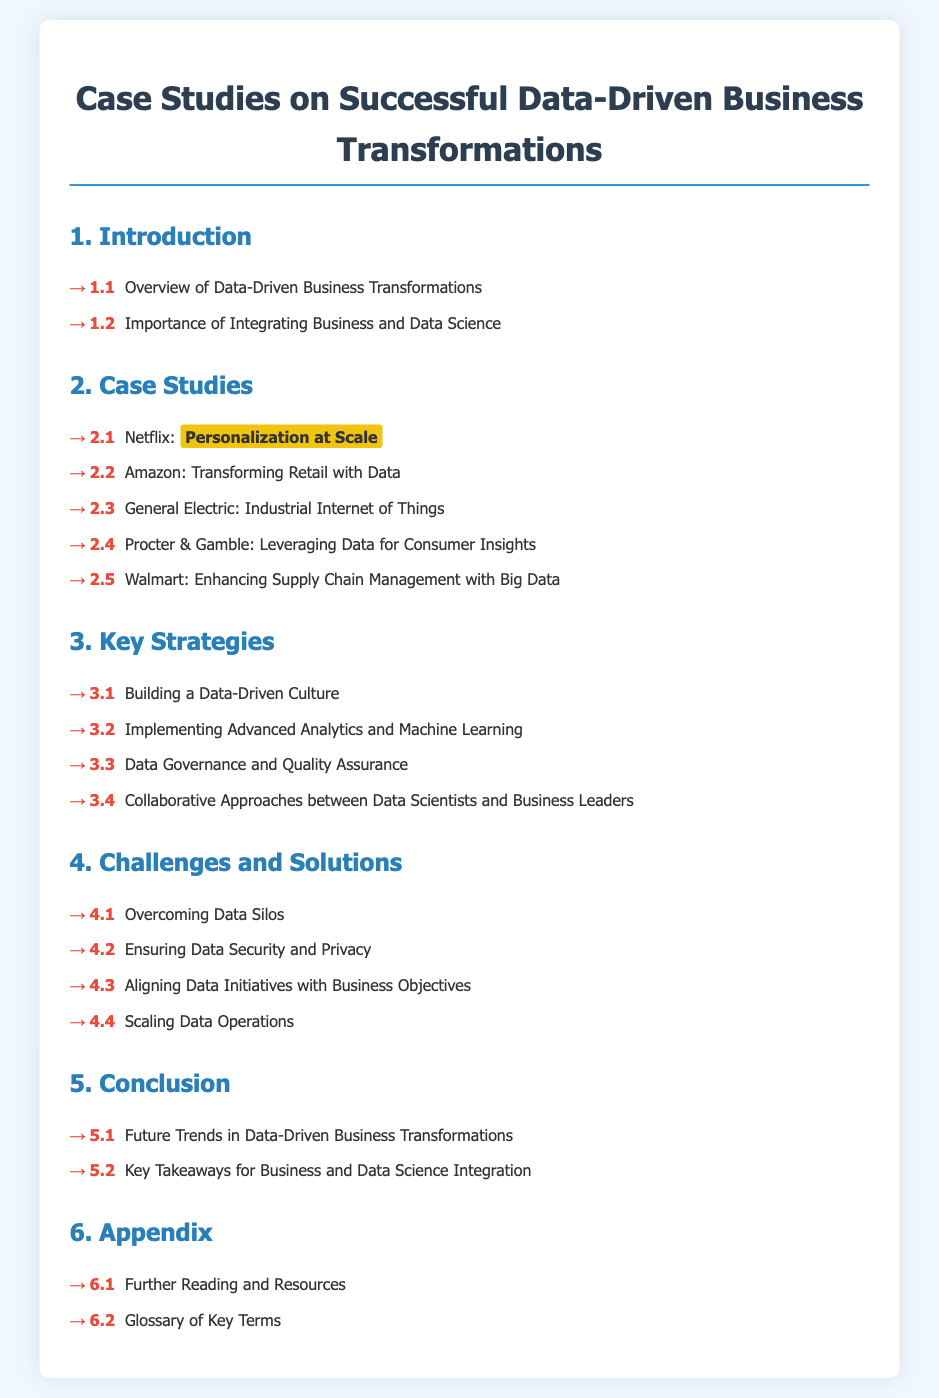what is the title of the document? The title is displayed prominently at the top of the document.
Answer: Case Studies on Successful Data-Driven Business Transformations how many case studies are listed in section 2? Each case study is listed under section 2 with specific numbering.
Answer: 5 which company is associated with 'Personalization at Scale'? The company is mentioned immediately next to its case study title.
Answer: Netflix what is the primary focus of section 3? Section 3 contains a list of strategies related to data-driven transformations.
Answer: Key Strategies which company is highlighted for enhancing supply chain management? The company is explicitly mentioned in the corresponding case study entry.
Answer: Walmart what is the main challenge discussed in section 4.1? Section 4.1 addresses specific challenges related to data-driven transformations.
Answer: Overcoming Data Silos what topic is covered in section 5.1? Section 5.1 discusses future developments and trends in a specific area.
Answer: Future Trends in Data-Driven Business Transformations how many sections does the document contain? The sections are numbered and counted throughout the document.
Answer: 6 